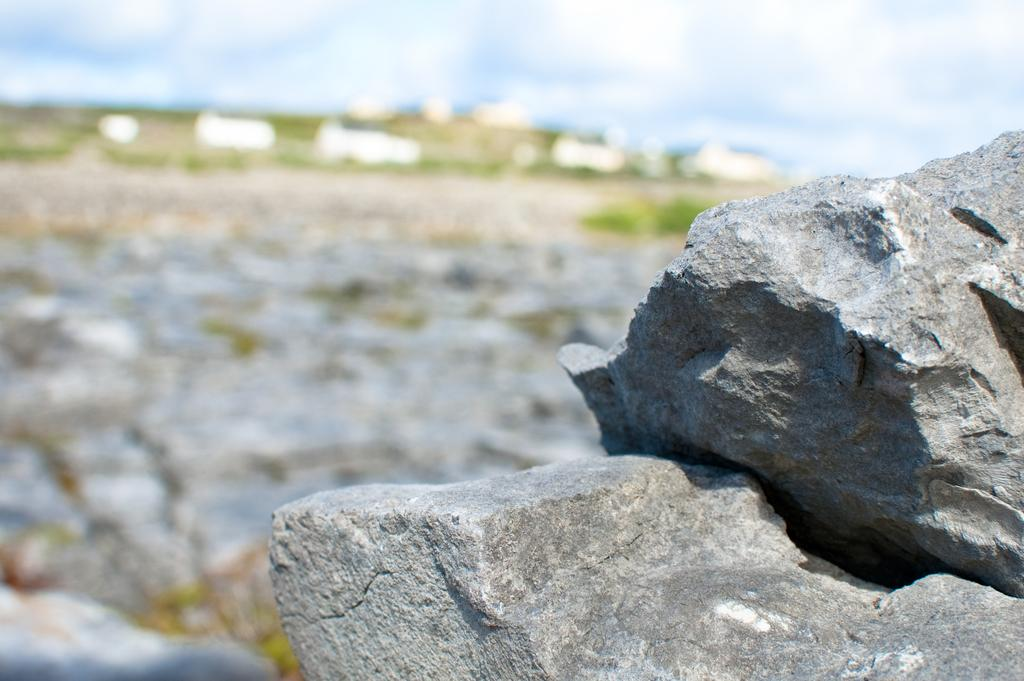What can be found in the bottom right side of the image? There are rocks in the bottom right side of the image. How would you describe the background of the image? The background of the image is blurred. What type of natural elements can be seen at the top of the image? There are clouds visible at the top of the image. What else is visible at the top of the image? The sky is visible at the top of the image. What type of worm can be seen wearing a dress in the image? There is no worm or dress present in the image. Can you tell me where the airport is located in the image? There is no airport present in the image. 